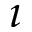<formula> <loc_0><loc_0><loc_500><loc_500>\imath</formula> 